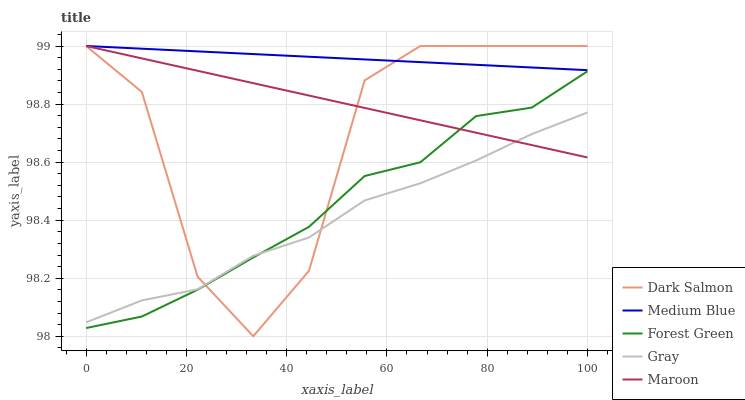Does Gray have the minimum area under the curve?
Answer yes or no. Yes. Does Medium Blue have the maximum area under the curve?
Answer yes or no. Yes. Does Forest Green have the minimum area under the curve?
Answer yes or no. No. Does Forest Green have the maximum area under the curve?
Answer yes or no. No. Is Medium Blue the smoothest?
Answer yes or no. Yes. Is Dark Salmon the roughest?
Answer yes or no. Yes. Is Forest Green the smoothest?
Answer yes or no. No. Is Forest Green the roughest?
Answer yes or no. No. Does Dark Salmon have the lowest value?
Answer yes or no. Yes. Does Forest Green have the lowest value?
Answer yes or no. No. Does Maroon have the highest value?
Answer yes or no. Yes. Does Forest Green have the highest value?
Answer yes or no. No. Is Forest Green less than Medium Blue?
Answer yes or no. Yes. Is Medium Blue greater than Forest Green?
Answer yes or no. Yes. Does Medium Blue intersect Maroon?
Answer yes or no. Yes. Is Medium Blue less than Maroon?
Answer yes or no. No. Is Medium Blue greater than Maroon?
Answer yes or no. No. Does Forest Green intersect Medium Blue?
Answer yes or no. No. 